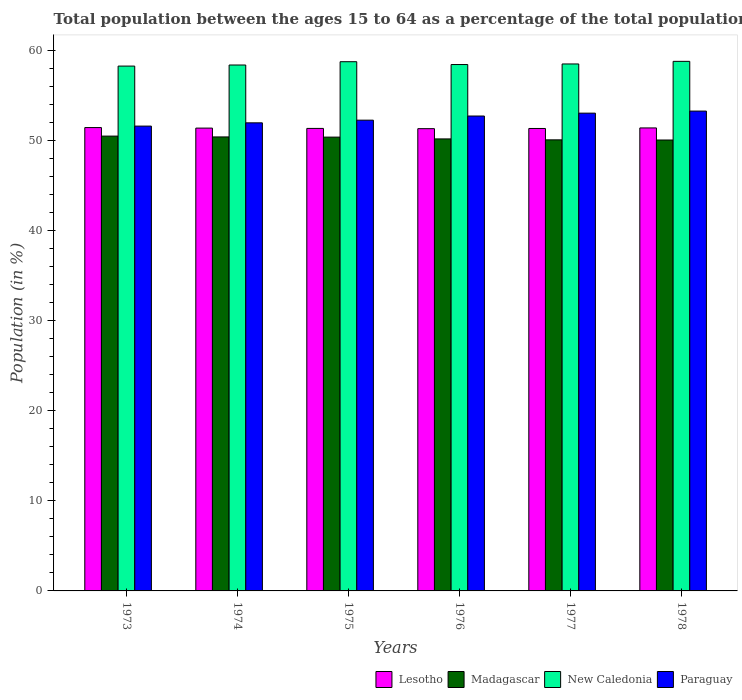How many different coloured bars are there?
Provide a succinct answer. 4. How many bars are there on the 5th tick from the left?
Make the answer very short. 4. How many bars are there on the 3rd tick from the right?
Make the answer very short. 4. What is the label of the 1st group of bars from the left?
Give a very brief answer. 1973. In how many cases, is the number of bars for a given year not equal to the number of legend labels?
Give a very brief answer. 0. What is the percentage of the population ages 15 to 64 in Paraguay in 1974?
Offer a very short reply. 51.95. Across all years, what is the maximum percentage of the population ages 15 to 64 in Madagascar?
Your answer should be compact. 50.48. Across all years, what is the minimum percentage of the population ages 15 to 64 in Madagascar?
Offer a terse response. 50.05. In which year was the percentage of the population ages 15 to 64 in Lesotho maximum?
Provide a succinct answer. 1973. What is the total percentage of the population ages 15 to 64 in Madagascar in the graph?
Give a very brief answer. 301.52. What is the difference between the percentage of the population ages 15 to 64 in Madagascar in 1974 and that in 1977?
Give a very brief answer. 0.32. What is the difference between the percentage of the population ages 15 to 64 in Madagascar in 1977 and the percentage of the population ages 15 to 64 in New Caledonia in 1976?
Ensure brevity in your answer.  -8.36. What is the average percentage of the population ages 15 to 64 in Lesotho per year?
Keep it short and to the point. 51.36. In the year 1978, what is the difference between the percentage of the population ages 15 to 64 in New Caledonia and percentage of the population ages 15 to 64 in Madagascar?
Keep it short and to the point. 8.73. What is the ratio of the percentage of the population ages 15 to 64 in New Caledonia in 1973 to that in 1977?
Your answer should be very brief. 1. Is the percentage of the population ages 15 to 64 in Madagascar in 1974 less than that in 1977?
Your answer should be very brief. No. What is the difference between the highest and the second highest percentage of the population ages 15 to 64 in Madagascar?
Offer a terse response. 0.09. What is the difference between the highest and the lowest percentage of the population ages 15 to 64 in Madagascar?
Offer a terse response. 0.43. What does the 1st bar from the left in 1973 represents?
Ensure brevity in your answer.  Lesotho. What does the 2nd bar from the right in 1978 represents?
Your answer should be very brief. New Caledonia. Is it the case that in every year, the sum of the percentage of the population ages 15 to 64 in Madagascar and percentage of the population ages 15 to 64 in New Caledonia is greater than the percentage of the population ages 15 to 64 in Paraguay?
Ensure brevity in your answer.  Yes. How many years are there in the graph?
Keep it short and to the point. 6. What is the difference between two consecutive major ticks on the Y-axis?
Keep it short and to the point. 10. Does the graph contain grids?
Make the answer very short. No. Where does the legend appear in the graph?
Ensure brevity in your answer.  Bottom right. How are the legend labels stacked?
Offer a terse response. Horizontal. What is the title of the graph?
Your response must be concise. Total population between the ages 15 to 64 as a percentage of the total population. Does "Switzerland" appear as one of the legend labels in the graph?
Provide a short and direct response. No. What is the label or title of the Y-axis?
Provide a short and direct response. Population (in %). What is the Population (in %) of Lesotho in 1973?
Provide a short and direct response. 51.43. What is the Population (in %) of Madagascar in 1973?
Make the answer very short. 50.48. What is the Population (in %) of New Caledonia in 1973?
Give a very brief answer. 58.25. What is the Population (in %) in Paraguay in 1973?
Your answer should be compact. 51.59. What is the Population (in %) in Lesotho in 1974?
Provide a short and direct response. 51.37. What is the Population (in %) in Madagascar in 1974?
Offer a terse response. 50.39. What is the Population (in %) in New Caledonia in 1974?
Your response must be concise. 58.37. What is the Population (in %) of Paraguay in 1974?
Your answer should be compact. 51.95. What is the Population (in %) of Lesotho in 1975?
Keep it short and to the point. 51.33. What is the Population (in %) in Madagascar in 1975?
Your answer should be compact. 50.37. What is the Population (in %) of New Caledonia in 1975?
Give a very brief answer. 58.74. What is the Population (in %) of Paraguay in 1975?
Your response must be concise. 52.25. What is the Population (in %) of Lesotho in 1976?
Make the answer very short. 51.31. What is the Population (in %) in Madagascar in 1976?
Ensure brevity in your answer.  50.17. What is the Population (in %) in New Caledonia in 1976?
Offer a very short reply. 58.42. What is the Population (in %) of Paraguay in 1976?
Your answer should be compact. 52.71. What is the Population (in %) of Lesotho in 1977?
Offer a very short reply. 51.33. What is the Population (in %) in Madagascar in 1977?
Provide a short and direct response. 50.06. What is the Population (in %) of New Caledonia in 1977?
Provide a succinct answer. 58.49. What is the Population (in %) in Paraguay in 1977?
Your answer should be very brief. 53.03. What is the Population (in %) of Lesotho in 1978?
Provide a succinct answer. 51.39. What is the Population (in %) of Madagascar in 1978?
Make the answer very short. 50.05. What is the Population (in %) in New Caledonia in 1978?
Offer a very short reply. 58.78. What is the Population (in %) in Paraguay in 1978?
Keep it short and to the point. 53.26. Across all years, what is the maximum Population (in %) of Lesotho?
Your answer should be compact. 51.43. Across all years, what is the maximum Population (in %) of Madagascar?
Make the answer very short. 50.48. Across all years, what is the maximum Population (in %) of New Caledonia?
Make the answer very short. 58.78. Across all years, what is the maximum Population (in %) in Paraguay?
Provide a succinct answer. 53.26. Across all years, what is the minimum Population (in %) in Lesotho?
Give a very brief answer. 51.31. Across all years, what is the minimum Population (in %) of Madagascar?
Your response must be concise. 50.05. Across all years, what is the minimum Population (in %) of New Caledonia?
Your response must be concise. 58.25. Across all years, what is the minimum Population (in %) in Paraguay?
Offer a very short reply. 51.59. What is the total Population (in %) in Lesotho in the graph?
Keep it short and to the point. 308.15. What is the total Population (in %) of Madagascar in the graph?
Your answer should be compact. 301.52. What is the total Population (in %) in New Caledonia in the graph?
Make the answer very short. 351.04. What is the total Population (in %) of Paraguay in the graph?
Give a very brief answer. 314.79. What is the difference between the Population (in %) in Lesotho in 1973 and that in 1974?
Your response must be concise. 0.06. What is the difference between the Population (in %) in Madagascar in 1973 and that in 1974?
Offer a terse response. 0.09. What is the difference between the Population (in %) of New Caledonia in 1973 and that in 1974?
Make the answer very short. -0.12. What is the difference between the Population (in %) of Paraguay in 1973 and that in 1974?
Ensure brevity in your answer.  -0.36. What is the difference between the Population (in %) in Lesotho in 1973 and that in 1975?
Provide a short and direct response. 0.09. What is the difference between the Population (in %) in Madagascar in 1973 and that in 1975?
Provide a succinct answer. 0.11. What is the difference between the Population (in %) in New Caledonia in 1973 and that in 1975?
Your answer should be compact. -0.49. What is the difference between the Population (in %) of Paraguay in 1973 and that in 1975?
Offer a terse response. -0.66. What is the difference between the Population (in %) in Lesotho in 1973 and that in 1976?
Your answer should be very brief. 0.12. What is the difference between the Population (in %) in Madagascar in 1973 and that in 1976?
Offer a terse response. 0.31. What is the difference between the Population (in %) in New Caledonia in 1973 and that in 1976?
Give a very brief answer. -0.17. What is the difference between the Population (in %) in Paraguay in 1973 and that in 1976?
Your answer should be compact. -1.12. What is the difference between the Population (in %) in Lesotho in 1973 and that in 1977?
Your response must be concise. 0.1. What is the difference between the Population (in %) in Madagascar in 1973 and that in 1977?
Offer a very short reply. 0.42. What is the difference between the Population (in %) in New Caledonia in 1973 and that in 1977?
Give a very brief answer. -0.24. What is the difference between the Population (in %) of Paraguay in 1973 and that in 1977?
Your answer should be compact. -1.44. What is the difference between the Population (in %) of Lesotho in 1973 and that in 1978?
Offer a terse response. 0.04. What is the difference between the Population (in %) in Madagascar in 1973 and that in 1978?
Your answer should be compact. 0.43. What is the difference between the Population (in %) of New Caledonia in 1973 and that in 1978?
Your answer should be compact. -0.53. What is the difference between the Population (in %) in Paraguay in 1973 and that in 1978?
Your answer should be very brief. -1.67. What is the difference between the Population (in %) of Lesotho in 1974 and that in 1975?
Your answer should be compact. 0.03. What is the difference between the Population (in %) in Madagascar in 1974 and that in 1975?
Keep it short and to the point. 0.02. What is the difference between the Population (in %) of New Caledonia in 1974 and that in 1975?
Provide a succinct answer. -0.37. What is the difference between the Population (in %) of Paraguay in 1974 and that in 1975?
Your answer should be compact. -0.3. What is the difference between the Population (in %) in Lesotho in 1974 and that in 1976?
Offer a terse response. 0.06. What is the difference between the Population (in %) in Madagascar in 1974 and that in 1976?
Your response must be concise. 0.22. What is the difference between the Population (in %) in New Caledonia in 1974 and that in 1976?
Your answer should be compact. -0.05. What is the difference between the Population (in %) of Paraguay in 1974 and that in 1976?
Offer a terse response. -0.76. What is the difference between the Population (in %) of Lesotho in 1974 and that in 1977?
Your answer should be very brief. 0.04. What is the difference between the Population (in %) in Madagascar in 1974 and that in 1977?
Your response must be concise. 0.32. What is the difference between the Population (in %) of New Caledonia in 1974 and that in 1977?
Make the answer very short. -0.12. What is the difference between the Population (in %) of Paraguay in 1974 and that in 1977?
Your answer should be compact. -1.08. What is the difference between the Population (in %) in Lesotho in 1974 and that in 1978?
Your answer should be very brief. -0.02. What is the difference between the Population (in %) in Madagascar in 1974 and that in 1978?
Provide a short and direct response. 0.34. What is the difference between the Population (in %) in New Caledonia in 1974 and that in 1978?
Provide a short and direct response. -0.41. What is the difference between the Population (in %) of Paraguay in 1974 and that in 1978?
Provide a succinct answer. -1.3. What is the difference between the Population (in %) of Lesotho in 1975 and that in 1976?
Offer a terse response. 0.03. What is the difference between the Population (in %) of Madagascar in 1975 and that in 1976?
Your response must be concise. 0.2. What is the difference between the Population (in %) of New Caledonia in 1975 and that in 1976?
Offer a very short reply. 0.31. What is the difference between the Population (in %) in Paraguay in 1975 and that in 1976?
Give a very brief answer. -0.46. What is the difference between the Population (in %) of Lesotho in 1975 and that in 1977?
Your answer should be very brief. 0.01. What is the difference between the Population (in %) of Madagascar in 1975 and that in 1977?
Your answer should be compact. 0.3. What is the difference between the Population (in %) in New Caledonia in 1975 and that in 1977?
Ensure brevity in your answer.  0.25. What is the difference between the Population (in %) in Paraguay in 1975 and that in 1977?
Offer a terse response. -0.78. What is the difference between the Population (in %) of Lesotho in 1975 and that in 1978?
Provide a succinct answer. -0.05. What is the difference between the Population (in %) in Madagascar in 1975 and that in 1978?
Offer a very short reply. 0.32. What is the difference between the Population (in %) of New Caledonia in 1975 and that in 1978?
Make the answer very short. -0.04. What is the difference between the Population (in %) of Paraguay in 1975 and that in 1978?
Keep it short and to the point. -1.01. What is the difference between the Population (in %) in Lesotho in 1976 and that in 1977?
Ensure brevity in your answer.  -0.02. What is the difference between the Population (in %) in Madagascar in 1976 and that in 1977?
Offer a terse response. 0.1. What is the difference between the Population (in %) of New Caledonia in 1976 and that in 1977?
Offer a terse response. -0.06. What is the difference between the Population (in %) of Paraguay in 1976 and that in 1977?
Make the answer very short. -0.32. What is the difference between the Population (in %) of Lesotho in 1976 and that in 1978?
Ensure brevity in your answer.  -0.08. What is the difference between the Population (in %) in Madagascar in 1976 and that in 1978?
Offer a very short reply. 0.12. What is the difference between the Population (in %) in New Caledonia in 1976 and that in 1978?
Ensure brevity in your answer.  -0.35. What is the difference between the Population (in %) of Paraguay in 1976 and that in 1978?
Provide a succinct answer. -0.55. What is the difference between the Population (in %) of Lesotho in 1977 and that in 1978?
Your answer should be very brief. -0.06. What is the difference between the Population (in %) of Madagascar in 1977 and that in 1978?
Provide a succinct answer. 0.02. What is the difference between the Population (in %) in New Caledonia in 1977 and that in 1978?
Provide a short and direct response. -0.29. What is the difference between the Population (in %) in Paraguay in 1977 and that in 1978?
Give a very brief answer. -0.23. What is the difference between the Population (in %) of Lesotho in 1973 and the Population (in %) of Madagascar in 1974?
Offer a terse response. 1.04. What is the difference between the Population (in %) of Lesotho in 1973 and the Population (in %) of New Caledonia in 1974?
Make the answer very short. -6.94. What is the difference between the Population (in %) of Lesotho in 1973 and the Population (in %) of Paraguay in 1974?
Provide a succinct answer. -0.53. What is the difference between the Population (in %) in Madagascar in 1973 and the Population (in %) in New Caledonia in 1974?
Keep it short and to the point. -7.89. What is the difference between the Population (in %) in Madagascar in 1973 and the Population (in %) in Paraguay in 1974?
Offer a very short reply. -1.47. What is the difference between the Population (in %) of New Caledonia in 1973 and the Population (in %) of Paraguay in 1974?
Your response must be concise. 6.3. What is the difference between the Population (in %) in Lesotho in 1973 and the Population (in %) in Madagascar in 1975?
Give a very brief answer. 1.06. What is the difference between the Population (in %) of Lesotho in 1973 and the Population (in %) of New Caledonia in 1975?
Your answer should be very brief. -7.31. What is the difference between the Population (in %) of Lesotho in 1973 and the Population (in %) of Paraguay in 1975?
Your response must be concise. -0.82. What is the difference between the Population (in %) of Madagascar in 1973 and the Population (in %) of New Caledonia in 1975?
Your response must be concise. -8.26. What is the difference between the Population (in %) of Madagascar in 1973 and the Population (in %) of Paraguay in 1975?
Your response must be concise. -1.77. What is the difference between the Population (in %) in New Caledonia in 1973 and the Population (in %) in Paraguay in 1975?
Provide a succinct answer. 6. What is the difference between the Population (in %) in Lesotho in 1973 and the Population (in %) in Madagascar in 1976?
Ensure brevity in your answer.  1.26. What is the difference between the Population (in %) in Lesotho in 1973 and the Population (in %) in New Caledonia in 1976?
Keep it short and to the point. -7. What is the difference between the Population (in %) of Lesotho in 1973 and the Population (in %) of Paraguay in 1976?
Keep it short and to the point. -1.28. What is the difference between the Population (in %) in Madagascar in 1973 and the Population (in %) in New Caledonia in 1976?
Your response must be concise. -7.94. What is the difference between the Population (in %) in Madagascar in 1973 and the Population (in %) in Paraguay in 1976?
Ensure brevity in your answer.  -2.23. What is the difference between the Population (in %) of New Caledonia in 1973 and the Population (in %) of Paraguay in 1976?
Your answer should be compact. 5.54. What is the difference between the Population (in %) of Lesotho in 1973 and the Population (in %) of Madagascar in 1977?
Keep it short and to the point. 1.36. What is the difference between the Population (in %) of Lesotho in 1973 and the Population (in %) of New Caledonia in 1977?
Provide a succinct answer. -7.06. What is the difference between the Population (in %) of Lesotho in 1973 and the Population (in %) of Paraguay in 1977?
Your answer should be very brief. -1.6. What is the difference between the Population (in %) in Madagascar in 1973 and the Population (in %) in New Caledonia in 1977?
Keep it short and to the point. -8.01. What is the difference between the Population (in %) in Madagascar in 1973 and the Population (in %) in Paraguay in 1977?
Provide a short and direct response. -2.55. What is the difference between the Population (in %) of New Caledonia in 1973 and the Population (in %) of Paraguay in 1977?
Ensure brevity in your answer.  5.22. What is the difference between the Population (in %) of Lesotho in 1973 and the Population (in %) of Madagascar in 1978?
Provide a succinct answer. 1.38. What is the difference between the Population (in %) in Lesotho in 1973 and the Population (in %) in New Caledonia in 1978?
Offer a very short reply. -7.35. What is the difference between the Population (in %) of Lesotho in 1973 and the Population (in %) of Paraguay in 1978?
Make the answer very short. -1.83. What is the difference between the Population (in %) of Madagascar in 1973 and the Population (in %) of New Caledonia in 1978?
Give a very brief answer. -8.3. What is the difference between the Population (in %) of Madagascar in 1973 and the Population (in %) of Paraguay in 1978?
Offer a terse response. -2.78. What is the difference between the Population (in %) of New Caledonia in 1973 and the Population (in %) of Paraguay in 1978?
Offer a terse response. 4.99. What is the difference between the Population (in %) of Lesotho in 1974 and the Population (in %) of New Caledonia in 1975?
Your answer should be compact. -7.37. What is the difference between the Population (in %) in Lesotho in 1974 and the Population (in %) in Paraguay in 1975?
Provide a succinct answer. -0.88. What is the difference between the Population (in %) of Madagascar in 1974 and the Population (in %) of New Caledonia in 1975?
Provide a short and direct response. -8.35. What is the difference between the Population (in %) of Madagascar in 1974 and the Population (in %) of Paraguay in 1975?
Give a very brief answer. -1.86. What is the difference between the Population (in %) in New Caledonia in 1974 and the Population (in %) in Paraguay in 1975?
Give a very brief answer. 6.12. What is the difference between the Population (in %) of Lesotho in 1974 and the Population (in %) of Madagascar in 1976?
Give a very brief answer. 1.2. What is the difference between the Population (in %) of Lesotho in 1974 and the Population (in %) of New Caledonia in 1976?
Provide a short and direct response. -7.05. What is the difference between the Population (in %) in Lesotho in 1974 and the Population (in %) in Paraguay in 1976?
Offer a very short reply. -1.34. What is the difference between the Population (in %) of Madagascar in 1974 and the Population (in %) of New Caledonia in 1976?
Provide a short and direct response. -8.03. What is the difference between the Population (in %) of Madagascar in 1974 and the Population (in %) of Paraguay in 1976?
Your answer should be very brief. -2.32. What is the difference between the Population (in %) in New Caledonia in 1974 and the Population (in %) in Paraguay in 1976?
Ensure brevity in your answer.  5.66. What is the difference between the Population (in %) of Lesotho in 1974 and the Population (in %) of Madagascar in 1977?
Provide a short and direct response. 1.3. What is the difference between the Population (in %) in Lesotho in 1974 and the Population (in %) in New Caledonia in 1977?
Your answer should be very brief. -7.12. What is the difference between the Population (in %) in Lesotho in 1974 and the Population (in %) in Paraguay in 1977?
Your response must be concise. -1.66. What is the difference between the Population (in %) of Madagascar in 1974 and the Population (in %) of New Caledonia in 1977?
Offer a terse response. -8.1. What is the difference between the Population (in %) of Madagascar in 1974 and the Population (in %) of Paraguay in 1977?
Offer a terse response. -2.64. What is the difference between the Population (in %) of New Caledonia in 1974 and the Population (in %) of Paraguay in 1977?
Offer a very short reply. 5.34. What is the difference between the Population (in %) in Lesotho in 1974 and the Population (in %) in Madagascar in 1978?
Offer a very short reply. 1.32. What is the difference between the Population (in %) in Lesotho in 1974 and the Population (in %) in New Caledonia in 1978?
Keep it short and to the point. -7.41. What is the difference between the Population (in %) in Lesotho in 1974 and the Population (in %) in Paraguay in 1978?
Give a very brief answer. -1.89. What is the difference between the Population (in %) in Madagascar in 1974 and the Population (in %) in New Caledonia in 1978?
Offer a terse response. -8.39. What is the difference between the Population (in %) in Madagascar in 1974 and the Population (in %) in Paraguay in 1978?
Your answer should be compact. -2.87. What is the difference between the Population (in %) of New Caledonia in 1974 and the Population (in %) of Paraguay in 1978?
Your answer should be compact. 5.11. What is the difference between the Population (in %) in Lesotho in 1975 and the Population (in %) in Madagascar in 1976?
Make the answer very short. 1.17. What is the difference between the Population (in %) in Lesotho in 1975 and the Population (in %) in New Caledonia in 1976?
Ensure brevity in your answer.  -7.09. What is the difference between the Population (in %) in Lesotho in 1975 and the Population (in %) in Paraguay in 1976?
Your response must be concise. -1.38. What is the difference between the Population (in %) of Madagascar in 1975 and the Population (in %) of New Caledonia in 1976?
Offer a terse response. -8.05. What is the difference between the Population (in %) in Madagascar in 1975 and the Population (in %) in Paraguay in 1976?
Provide a short and direct response. -2.34. What is the difference between the Population (in %) of New Caledonia in 1975 and the Population (in %) of Paraguay in 1976?
Provide a succinct answer. 6.03. What is the difference between the Population (in %) in Lesotho in 1975 and the Population (in %) in Madagascar in 1977?
Make the answer very short. 1.27. What is the difference between the Population (in %) in Lesotho in 1975 and the Population (in %) in New Caledonia in 1977?
Provide a succinct answer. -7.15. What is the difference between the Population (in %) in Lesotho in 1975 and the Population (in %) in Paraguay in 1977?
Provide a succinct answer. -1.69. What is the difference between the Population (in %) in Madagascar in 1975 and the Population (in %) in New Caledonia in 1977?
Keep it short and to the point. -8.12. What is the difference between the Population (in %) of Madagascar in 1975 and the Population (in %) of Paraguay in 1977?
Provide a short and direct response. -2.66. What is the difference between the Population (in %) of New Caledonia in 1975 and the Population (in %) of Paraguay in 1977?
Give a very brief answer. 5.71. What is the difference between the Population (in %) in Lesotho in 1975 and the Population (in %) in Madagascar in 1978?
Offer a very short reply. 1.29. What is the difference between the Population (in %) of Lesotho in 1975 and the Population (in %) of New Caledonia in 1978?
Offer a very short reply. -7.44. What is the difference between the Population (in %) in Lesotho in 1975 and the Population (in %) in Paraguay in 1978?
Provide a short and direct response. -1.92. What is the difference between the Population (in %) in Madagascar in 1975 and the Population (in %) in New Caledonia in 1978?
Ensure brevity in your answer.  -8.41. What is the difference between the Population (in %) in Madagascar in 1975 and the Population (in %) in Paraguay in 1978?
Your answer should be very brief. -2.89. What is the difference between the Population (in %) in New Caledonia in 1975 and the Population (in %) in Paraguay in 1978?
Ensure brevity in your answer.  5.48. What is the difference between the Population (in %) of Lesotho in 1976 and the Population (in %) of Madagascar in 1977?
Your response must be concise. 1.24. What is the difference between the Population (in %) of Lesotho in 1976 and the Population (in %) of New Caledonia in 1977?
Give a very brief answer. -7.18. What is the difference between the Population (in %) of Lesotho in 1976 and the Population (in %) of Paraguay in 1977?
Ensure brevity in your answer.  -1.72. What is the difference between the Population (in %) of Madagascar in 1976 and the Population (in %) of New Caledonia in 1977?
Offer a very short reply. -8.32. What is the difference between the Population (in %) of Madagascar in 1976 and the Population (in %) of Paraguay in 1977?
Your response must be concise. -2.86. What is the difference between the Population (in %) of New Caledonia in 1976 and the Population (in %) of Paraguay in 1977?
Ensure brevity in your answer.  5.39. What is the difference between the Population (in %) in Lesotho in 1976 and the Population (in %) in Madagascar in 1978?
Provide a short and direct response. 1.26. What is the difference between the Population (in %) in Lesotho in 1976 and the Population (in %) in New Caledonia in 1978?
Keep it short and to the point. -7.47. What is the difference between the Population (in %) of Lesotho in 1976 and the Population (in %) of Paraguay in 1978?
Offer a terse response. -1.95. What is the difference between the Population (in %) in Madagascar in 1976 and the Population (in %) in New Caledonia in 1978?
Offer a very short reply. -8.61. What is the difference between the Population (in %) of Madagascar in 1976 and the Population (in %) of Paraguay in 1978?
Your answer should be compact. -3.09. What is the difference between the Population (in %) in New Caledonia in 1976 and the Population (in %) in Paraguay in 1978?
Offer a terse response. 5.17. What is the difference between the Population (in %) in Lesotho in 1977 and the Population (in %) in Madagascar in 1978?
Provide a short and direct response. 1.28. What is the difference between the Population (in %) in Lesotho in 1977 and the Population (in %) in New Caledonia in 1978?
Your answer should be very brief. -7.45. What is the difference between the Population (in %) in Lesotho in 1977 and the Population (in %) in Paraguay in 1978?
Provide a short and direct response. -1.93. What is the difference between the Population (in %) of Madagascar in 1977 and the Population (in %) of New Caledonia in 1978?
Your response must be concise. -8.71. What is the difference between the Population (in %) in Madagascar in 1977 and the Population (in %) in Paraguay in 1978?
Your answer should be very brief. -3.19. What is the difference between the Population (in %) of New Caledonia in 1977 and the Population (in %) of Paraguay in 1978?
Provide a short and direct response. 5.23. What is the average Population (in %) of Lesotho per year?
Give a very brief answer. 51.36. What is the average Population (in %) of Madagascar per year?
Your response must be concise. 50.25. What is the average Population (in %) of New Caledonia per year?
Your answer should be very brief. 58.51. What is the average Population (in %) in Paraguay per year?
Provide a succinct answer. 52.46. In the year 1973, what is the difference between the Population (in %) of Lesotho and Population (in %) of Madagascar?
Ensure brevity in your answer.  0.95. In the year 1973, what is the difference between the Population (in %) of Lesotho and Population (in %) of New Caledonia?
Your answer should be very brief. -6.82. In the year 1973, what is the difference between the Population (in %) of Lesotho and Population (in %) of Paraguay?
Ensure brevity in your answer.  -0.16. In the year 1973, what is the difference between the Population (in %) of Madagascar and Population (in %) of New Caledonia?
Ensure brevity in your answer.  -7.77. In the year 1973, what is the difference between the Population (in %) of Madagascar and Population (in %) of Paraguay?
Provide a short and direct response. -1.11. In the year 1973, what is the difference between the Population (in %) of New Caledonia and Population (in %) of Paraguay?
Your answer should be very brief. 6.66. In the year 1974, what is the difference between the Population (in %) in Lesotho and Population (in %) in Madagascar?
Provide a succinct answer. 0.98. In the year 1974, what is the difference between the Population (in %) in Lesotho and Population (in %) in New Caledonia?
Offer a terse response. -7. In the year 1974, what is the difference between the Population (in %) in Lesotho and Population (in %) in Paraguay?
Offer a very short reply. -0.59. In the year 1974, what is the difference between the Population (in %) of Madagascar and Population (in %) of New Caledonia?
Ensure brevity in your answer.  -7.98. In the year 1974, what is the difference between the Population (in %) of Madagascar and Population (in %) of Paraguay?
Offer a terse response. -1.56. In the year 1974, what is the difference between the Population (in %) of New Caledonia and Population (in %) of Paraguay?
Keep it short and to the point. 6.42. In the year 1975, what is the difference between the Population (in %) in Lesotho and Population (in %) in Madagascar?
Your answer should be compact. 0.97. In the year 1975, what is the difference between the Population (in %) in Lesotho and Population (in %) in New Caledonia?
Offer a very short reply. -7.4. In the year 1975, what is the difference between the Population (in %) in Lesotho and Population (in %) in Paraguay?
Your response must be concise. -0.92. In the year 1975, what is the difference between the Population (in %) in Madagascar and Population (in %) in New Caledonia?
Your response must be concise. -8.37. In the year 1975, what is the difference between the Population (in %) of Madagascar and Population (in %) of Paraguay?
Your answer should be compact. -1.88. In the year 1975, what is the difference between the Population (in %) in New Caledonia and Population (in %) in Paraguay?
Offer a terse response. 6.49. In the year 1976, what is the difference between the Population (in %) of Lesotho and Population (in %) of Madagascar?
Your answer should be compact. 1.14. In the year 1976, what is the difference between the Population (in %) of Lesotho and Population (in %) of New Caledonia?
Ensure brevity in your answer.  -7.12. In the year 1976, what is the difference between the Population (in %) of Lesotho and Population (in %) of Paraguay?
Give a very brief answer. -1.4. In the year 1976, what is the difference between the Population (in %) of Madagascar and Population (in %) of New Caledonia?
Offer a very short reply. -8.25. In the year 1976, what is the difference between the Population (in %) in Madagascar and Population (in %) in Paraguay?
Ensure brevity in your answer.  -2.54. In the year 1976, what is the difference between the Population (in %) of New Caledonia and Population (in %) of Paraguay?
Your answer should be compact. 5.71. In the year 1977, what is the difference between the Population (in %) of Lesotho and Population (in %) of Madagascar?
Give a very brief answer. 1.26. In the year 1977, what is the difference between the Population (in %) of Lesotho and Population (in %) of New Caledonia?
Provide a succinct answer. -7.16. In the year 1977, what is the difference between the Population (in %) of Lesotho and Population (in %) of Paraguay?
Ensure brevity in your answer.  -1.7. In the year 1977, what is the difference between the Population (in %) of Madagascar and Population (in %) of New Caledonia?
Give a very brief answer. -8.42. In the year 1977, what is the difference between the Population (in %) of Madagascar and Population (in %) of Paraguay?
Provide a succinct answer. -2.96. In the year 1977, what is the difference between the Population (in %) in New Caledonia and Population (in %) in Paraguay?
Your response must be concise. 5.46. In the year 1978, what is the difference between the Population (in %) in Lesotho and Population (in %) in Madagascar?
Offer a terse response. 1.34. In the year 1978, what is the difference between the Population (in %) in Lesotho and Population (in %) in New Caledonia?
Provide a succinct answer. -7.39. In the year 1978, what is the difference between the Population (in %) in Lesotho and Population (in %) in Paraguay?
Provide a succinct answer. -1.87. In the year 1978, what is the difference between the Population (in %) in Madagascar and Population (in %) in New Caledonia?
Your response must be concise. -8.73. In the year 1978, what is the difference between the Population (in %) of Madagascar and Population (in %) of Paraguay?
Provide a short and direct response. -3.21. In the year 1978, what is the difference between the Population (in %) in New Caledonia and Population (in %) in Paraguay?
Your answer should be very brief. 5.52. What is the ratio of the Population (in %) of New Caledonia in 1973 to that in 1974?
Provide a succinct answer. 1. What is the ratio of the Population (in %) in Paraguay in 1973 to that in 1975?
Your answer should be compact. 0.99. What is the ratio of the Population (in %) of Lesotho in 1973 to that in 1976?
Your response must be concise. 1. What is the ratio of the Population (in %) in Madagascar in 1973 to that in 1976?
Offer a very short reply. 1.01. What is the ratio of the Population (in %) in New Caledonia in 1973 to that in 1976?
Offer a terse response. 1. What is the ratio of the Population (in %) of Paraguay in 1973 to that in 1976?
Provide a succinct answer. 0.98. What is the ratio of the Population (in %) of Lesotho in 1973 to that in 1977?
Give a very brief answer. 1. What is the ratio of the Population (in %) in Madagascar in 1973 to that in 1977?
Offer a terse response. 1.01. What is the ratio of the Population (in %) of Paraguay in 1973 to that in 1977?
Offer a terse response. 0.97. What is the ratio of the Population (in %) in Lesotho in 1973 to that in 1978?
Keep it short and to the point. 1. What is the ratio of the Population (in %) of Madagascar in 1973 to that in 1978?
Offer a very short reply. 1.01. What is the ratio of the Population (in %) of New Caledonia in 1973 to that in 1978?
Offer a very short reply. 0.99. What is the ratio of the Population (in %) in Paraguay in 1973 to that in 1978?
Your answer should be compact. 0.97. What is the ratio of the Population (in %) in Lesotho in 1974 to that in 1975?
Your answer should be compact. 1. What is the ratio of the Population (in %) of New Caledonia in 1974 to that in 1976?
Ensure brevity in your answer.  1. What is the ratio of the Population (in %) in Paraguay in 1974 to that in 1976?
Provide a short and direct response. 0.99. What is the ratio of the Population (in %) in Lesotho in 1974 to that in 1977?
Provide a short and direct response. 1. What is the ratio of the Population (in %) of Madagascar in 1974 to that in 1977?
Make the answer very short. 1.01. What is the ratio of the Population (in %) in New Caledonia in 1974 to that in 1977?
Provide a succinct answer. 1. What is the ratio of the Population (in %) of Paraguay in 1974 to that in 1977?
Provide a succinct answer. 0.98. What is the ratio of the Population (in %) in Lesotho in 1974 to that in 1978?
Offer a very short reply. 1. What is the ratio of the Population (in %) in Madagascar in 1974 to that in 1978?
Ensure brevity in your answer.  1.01. What is the ratio of the Population (in %) in Paraguay in 1974 to that in 1978?
Your answer should be compact. 0.98. What is the ratio of the Population (in %) in Lesotho in 1975 to that in 1976?
Offer a terse response. 1. What is the ratio of the Population (in %) in New Caledonia in 1975 to that in 1976?
Offer a very short reply. 1.01. What is the ratio of the Population (in %) in New Caledonia in 1975 to that in 1977?
Your response must be concise. 1. What is the ratio of the Population (in %) in Paraguay in 1975 to that in 1977?
Provide a succinct answer. 0.99. What is the ratio of the Population (in %) in Lesotho in 1975 to that in 1978?
Keep it short and to the point. 1. What is the ratio of the Population (in %) of Madagascar in 1975 to that in 1978?
Provide a short and direct response. 1.01. What is the ratio of the Population (in %) in New Caledonia in 1975 to that in 1978?
Keep it short and to the point. 1. What is the ratio of the Population (in %) in Paraguay in 1975 to that in 1978?
Your answer should be very brief. 0.98. What is the ratio of the Population (in %) of Paraguay in 1976 to that in 1977?
Ensure brevity in your answer.  0.99. What is the ratio of the Population (in %) of Madagascar in 1976 to that in 1978?
Your response must be concise. 1. What is the ratio of the Population (in %) in Paraguay in 1976 to that in 1978?
Your answer should be compact. 0.99. What is the ratio of the Population (in %) in New Caledonia in 1977 to that in 1978?
Your answer should be compact. 1. What is the ratio of the Population (in %) in Paraguay in 1977 to that in 1978?
Ensure brevity in your answer.  1. What is the difference between the highest and the second highest Population (in %) in Lesotho?
Provide a succinct answer. 0.04. What is the difference between the highest and the second highest Population (in %) of Madagascar?
Ensure brevity in your answer.  0.09. What is the difference between the highest and the second highest Population (in %) of New Caledonia?
Your answer should be very brief. 0.04. What is the difference between the highest and the second highest Population (in %) of Paraguay?
Offer a very short reply. 0.23. What is the difference between the highest and the lowest Population (in %) of Lesotho?
Your response must be concise. 0.12. What is the difference between the highest and the lowest Population (in %) of Madagascar?
Your response must be concise. 0.43. What is the difference between the highest and the lowest Population (in %) in New Caledonia?
Provide a short and direct response. 0.53. What is the difference between the highest and the lowest Population (in %) of Paraguay?
Your answer should be very brief. 1.67. 